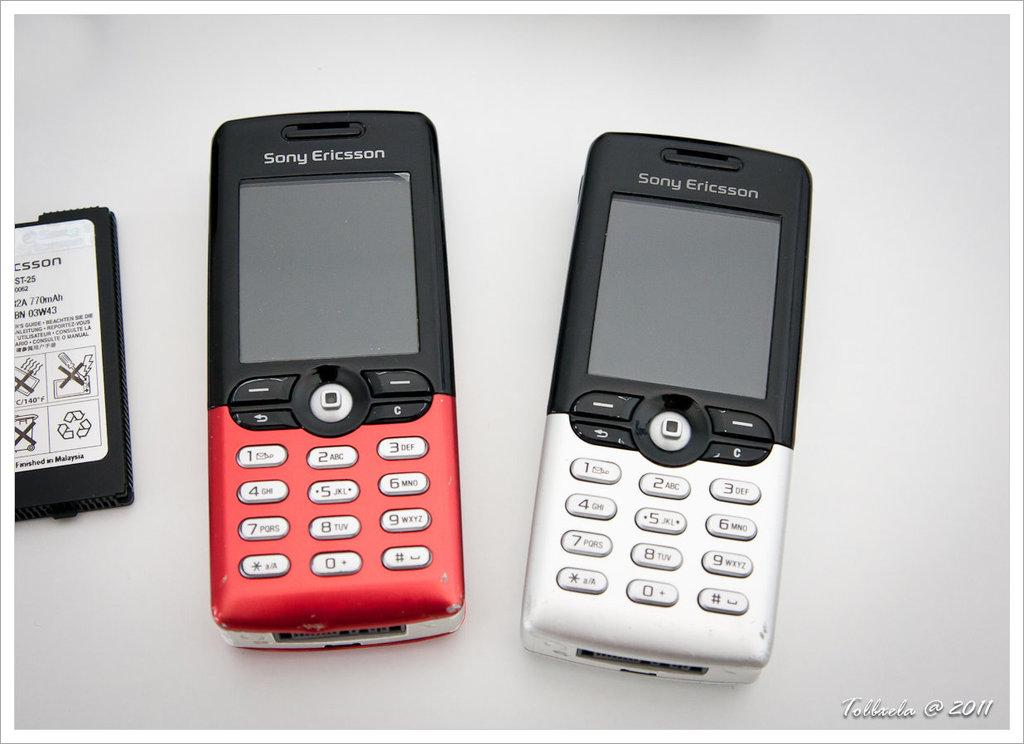<image>
Render a clear and concise summary of the photo. A battery sits next to 2 Sony Ericcson phones, one red and one white. 